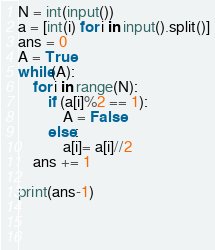<code> <loc_0><loc_0><loc_500><loc_500><_Python_>N = int(input())
a = [int(i) for i in input().split()]
ans = 0
A = True
while(A):
    for i in range(N):
        if (a[i]%2 == 1):
            A = False
        else:
            a[i]= a[i]//2
    ans += 1

print(ans-1)
            
            
    </code> 